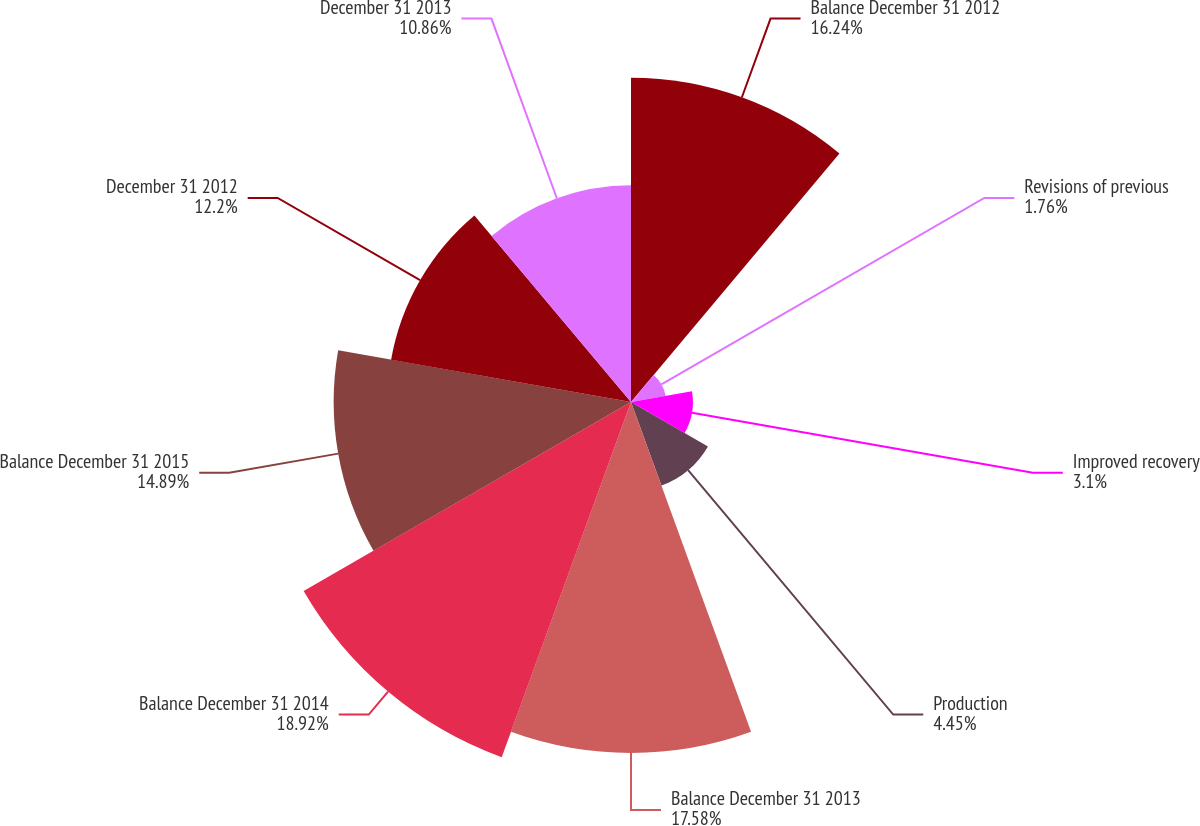<chart> <loc_0><loc_0><loc_500><loc_500><pie_chart><fcel>Balance December 31 2012<fcel>Revisions of previous<fcel>Improved recovery<fcel>Production<fcel>Balance December 31 2013<fcel>Balance December 31 2014<fcel>Balance December 31 2015<fcel>December 31 2012<fcel>December 31 2013<nl><fcel>16.24%<fcel>1.76%<fcel>3.1%<fcel>4.45%<fcel>17.58%<fcel>18.93%<fcel>14.89%<fcel>12.2%<fcel>10.86%<nl></chart> 